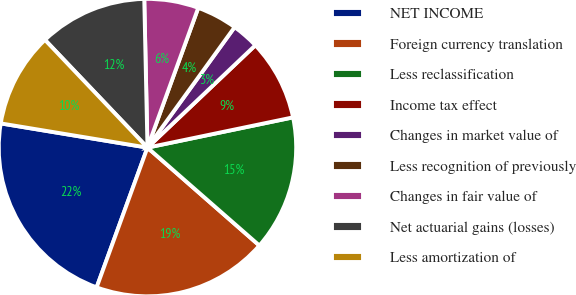Convert chart. <chart><loc_0><loc_0><loc_500><loc_500><pie_chart><fcel>NET INCOME<fcel>Foreign currency translation<fcel>Less reclassification<fcel>Income tax effect<fcel>Changes in market value of<fcel>Less recognition of previously<fcel>Changes in fair value of<fcel>Net actuarial gains (losses)<fcel>Less amortization of<nl><fcel>22.05%<fcel>19.11%<fcel>14.7%<fcel>8.82%<fcel>2.95%<fcel>4.42%<fcel>5.89%<fcel>11.76%<fcel>10.29%<nl></chart> 